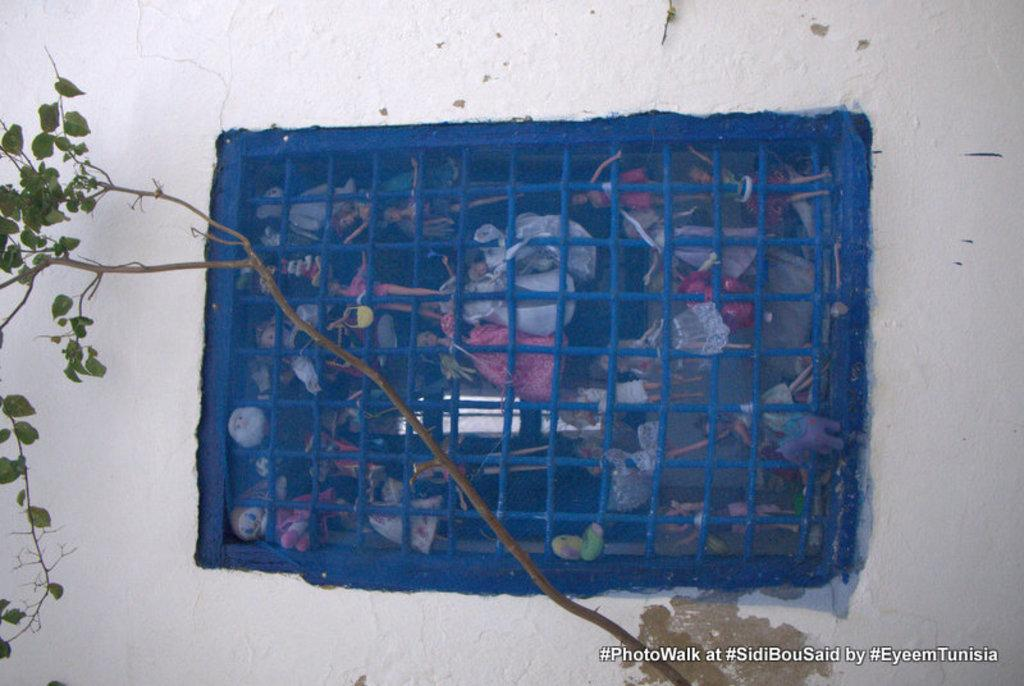What is located in the center of the picture? There is a window in the center of the picture. What can be seen through the window? Toys are visible inside the window. What is at the bottom of the picture? There is a tree at the bottom of the picture. What color is the wall in the picture? The wall in the picture is painted white. What type of destruction can be seen in the garden in the image? There is no garden or destruction present in the image; it features a window with toys inside, a tree at the bottom, and a white wall. 